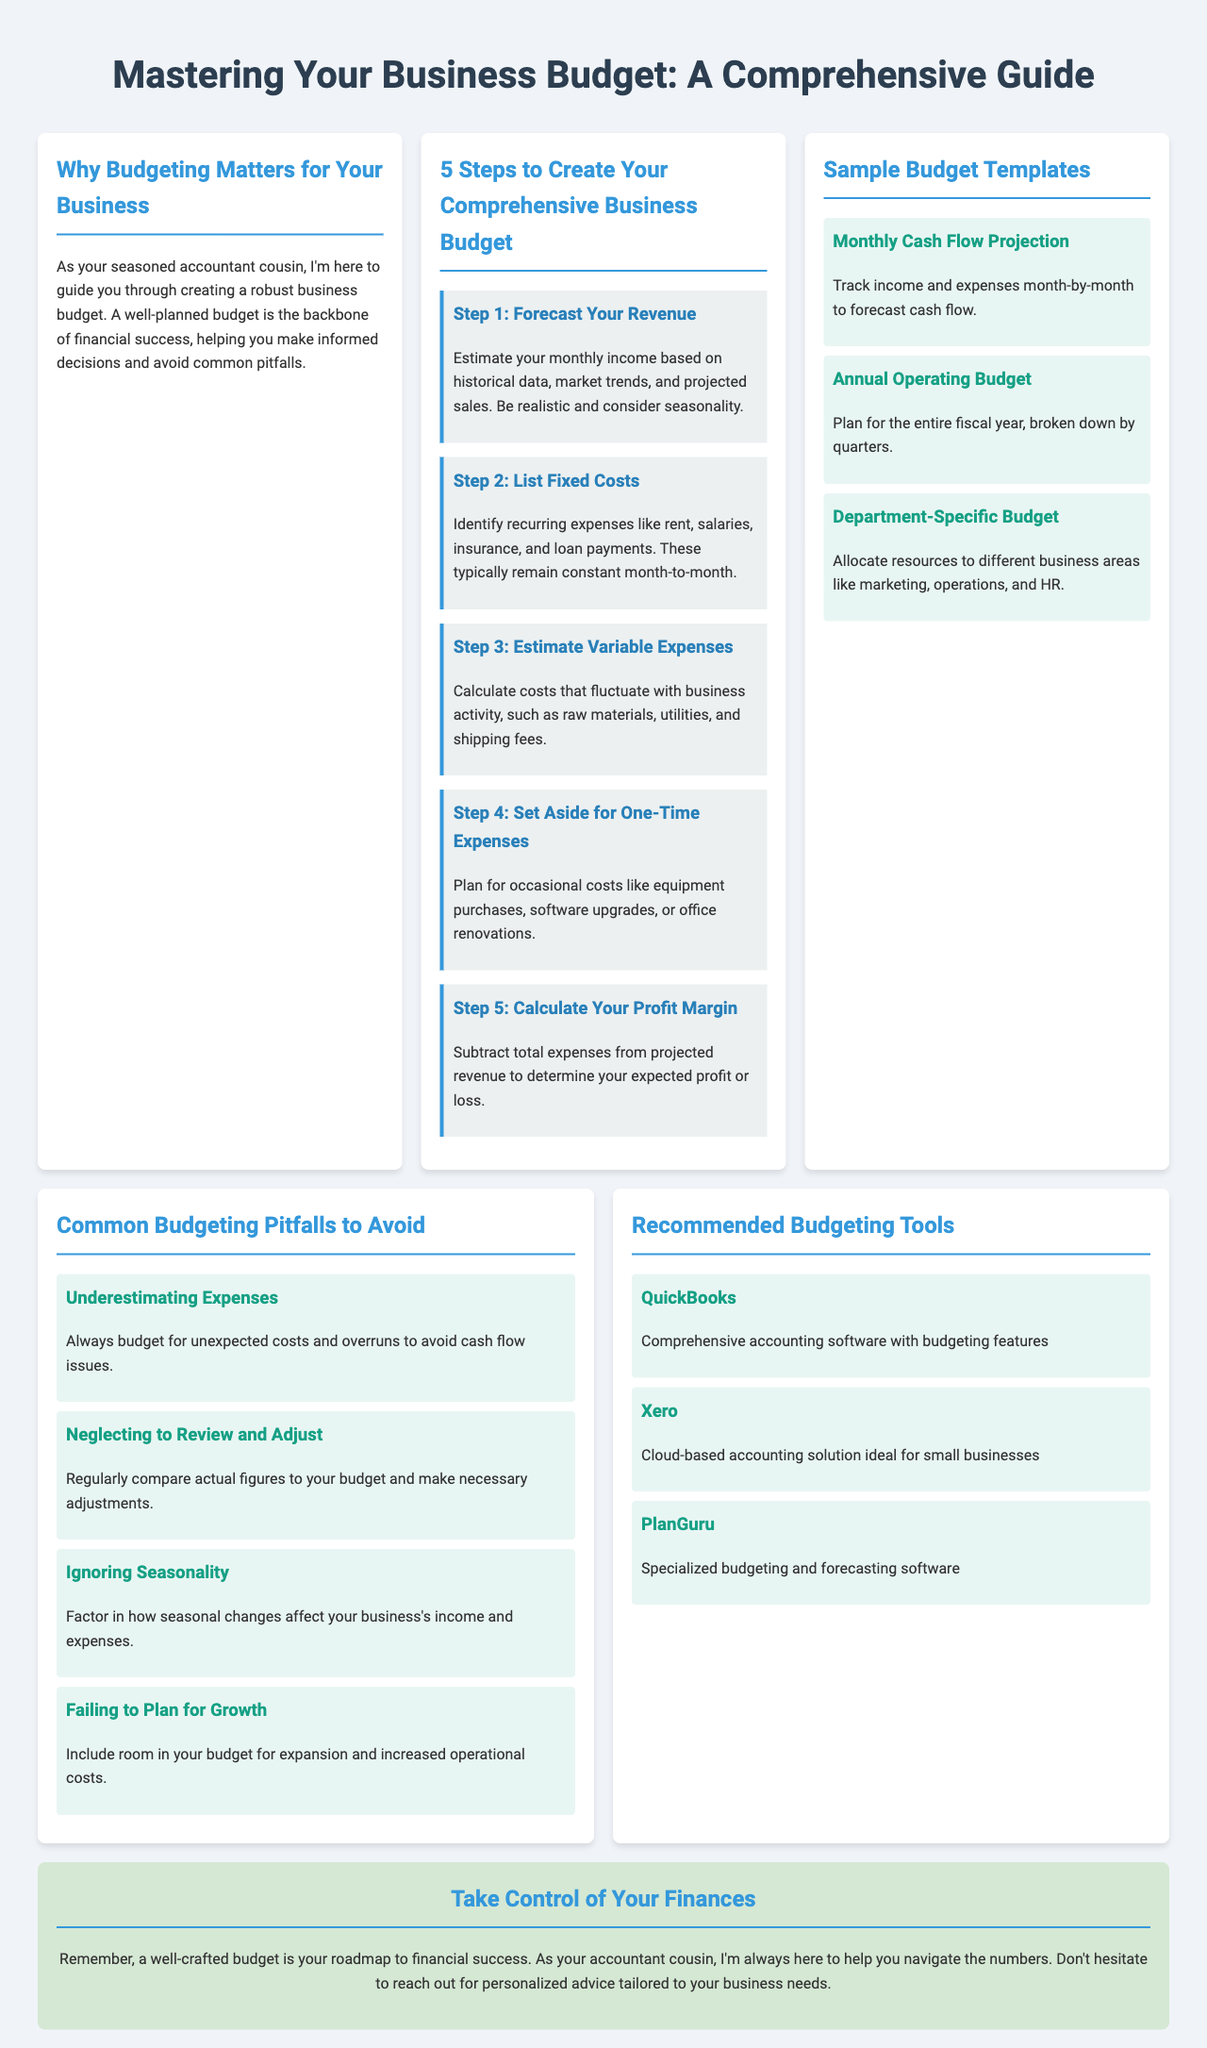What is the title of the brochure? The title is mentioned at the top of the document as the main heading.
Answer: Mastering Your Business Budget: A Comprehensive Guide What is the first step in creating a budget? The steps are clearly outlined, and the first one is listed for easy reference.
Answer: Forecast Your Revenue What type of expenses does Step 2 refer to? The document specifies a category of expenses to be identified during the budgeting process.
Answer: Fixed Costs How many sample budget templates are provided? The section lists the different templates available for reference in budgeting.
Answer: Three What common pitfall involves unexpected costs? This question refers to a specific issue identified in the pitfalls section.
Answer: Underestimating Expenses Which budgeting tool is mentioned as cloud-based? The tools section lists different software tools for budgeting, and one is specified as cloud-based.
Answer: Xero What color is used for the section titles in the brochure? The style section details the design choices for headings throughout the document.
Answer: Blue What is the main purpose of a business budget according to the introduction? The introduction states the fundamental reason for preparing a budget.
Answer: Financial success What is advised to include in the budget for business growth? This inquiry relates to planning considerations mentioned in the document.
Answer: Room for expansion 